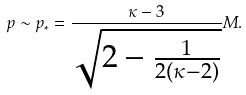<formula> <loc_0><loc_0><loc_500><loc_500>p \sim p _ { * } = \frac { \kappa - 3 } { \sqrt { 2 - \frac { 1 } { 2 ( \kappa - 2 ) } } } M .</formula> 